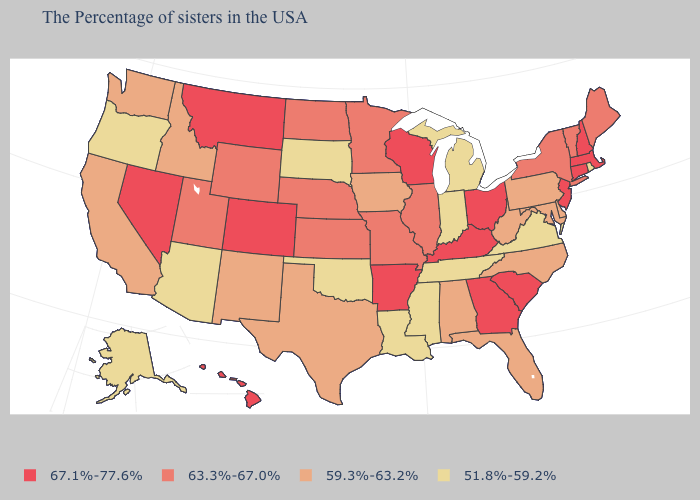Does Michigan have a higher value than Montana?
Give a very brief answer. No. Name the states that have a value in the range 59.3%-63.2%?
Keep it brief. Delaware, Maryland, Pennsylvania, North Carolina, West Virginia, Florida, Alabama, Iowa, Texas, New Mexico, Idaho, California, Washington. Does New Jersey have the same value as New Hampshire?
Concise answer only. Yes. Which states hav the highest value in the West?
Write a very short answer. Colorado, Montana, Nevada, Hawaii. What is the value of Hawaii?
Write a very short answer. 67.1%-77.6%. Name the states that have a value in the range 67.1%-77.6%?
Keep it brief. Massachusetts, New Hampshire, Connecticut, New Jersey, South Carolina, Ohio, Georgia, Kentucky, Wisconsin, Arkansas, Colorado, Montana, Nevada, Hawaii. Name the states that have a value in the range 59.3%-63.2%?
Quick response, please. Delaware, Maryland, Pennsylvania, North Carolina, West Virginia, Florida, Alabama, Iowa, Texas, New Mexico, Idaho, California, Washington. What is the value of Connecticut?
Short answer required. 67.1%-77.6%. What is the value of Tennessee?
Be succinct. 51.8%-59.2%. What is the highest value in the USA?
Quick response, please. 67.1%-77.6%. Which states have the highest value in the USA?
Keep it brief. Massachusetts, New Hampshire, Connecticut, New Jersey, South Carolina, Ohio, Georgia, Kentucky, Wisconsin, Arkansas, Colorado, Montana, Nevada, Hawaii. Among the states that border Wyoming , does Utah have the lowest value?
Give a very brief answer. No. Name the states that have a value in the range 67.1%-77.6%?
Give a very brief answer. Massachusetts, New Hampshire, Connecticut, New Jersey, South Carolina, Ohio, Georgia, Kentucky, Wisconsin, Arkansas, Colorado, Montana, Nevada, Hawaii. Name the states that have a value in the range 63.3%-67.0%?
Give a very brief answer. Maine, Vermont, New York, Illinois, Missouri, Minnesota, Kansas, Nebraska, North Dakota, Wyoming, Utah. Which states hav the highest value in the Northeast?
Write a very short answer. Massachusetts, New Hampshire, Connecticut, New Jersey. 